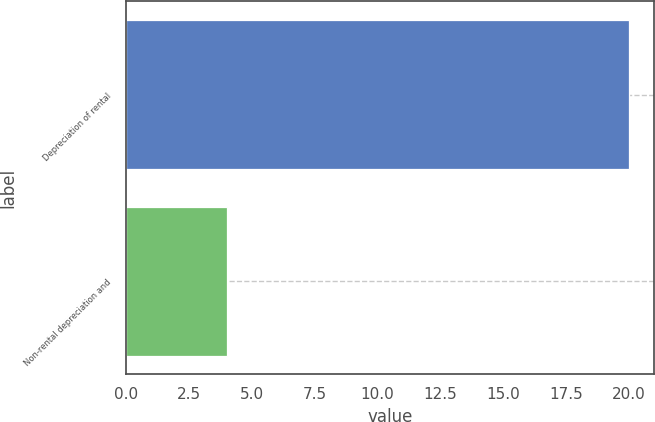Convert chart to OTSL. <chart><loc_0><loc_0><loc_500><loc_500><bar_chart><fcel>Depreciation of rental<fcel>Non-rental depreciation and<nl><fcel>20<fcel>4<nl></chart> 